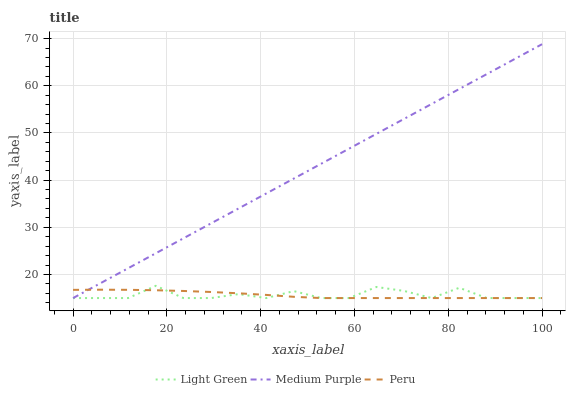Does Peru have the minimum area under the curve?
Answer yes or no. Yes. Does Medium Purple have the maximum area under the curve?
Answer yes or no. Yes. Does Light Green have the minimum area under the curve?
Answer yes or no. No. Does Light Green have the maximum area under the curve?
Answer yes or no. No. Is Medium Purple the smoothest?
Answer yes or no. Yes. Is Light Green the roughest?
Answer yes or no. Yes. Is Peru the smoothest?
Answer yes or no. No. Is Peru the roughest?
Answer yes or no. No. Does Medium Purple have the lowest value?
Answer yes or no. Yes. Does Medium Purple have the highest value?
Answer yes or no. Yes. Does Light Green have the highest value?
Answer yes or no. No. Does Peru intersect Light Green?
Answer yes or no. Yes. Is Peru less than Light Green?
Answer yes or no. No. Is Peru greater than Light Green?
Answer yes or no. No. 